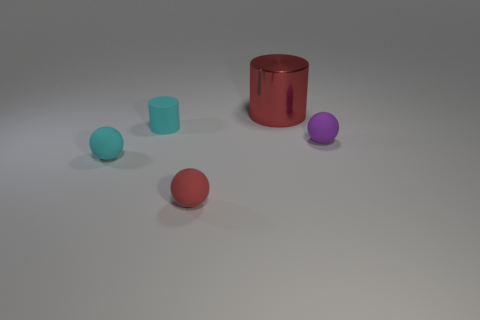Add 4 red matte cubes. How many objects exist? 9 Subtract all cylinders. How many objects are left? 3 Subtract all small purple spheres. Subtract all purple spheres. How many objects are left? 3 Add 4 cyan balls. How many cyan balls are left? 5 Add 4 tiny rubber cylinders. How many tiny rubber cylinders exist? 5 Subtract 0 green spheres. How many objects are left? 5 